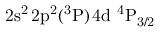Convert formula to latex. <formula><loc_0><loc_0><loc_500><loc_500>2 s ^ { 2 } \, 2 p ^ { 2 } ( ^ { 3 } P ) \, 4 d ^ { 4 } P _ { 3 / 2 }</formula> 